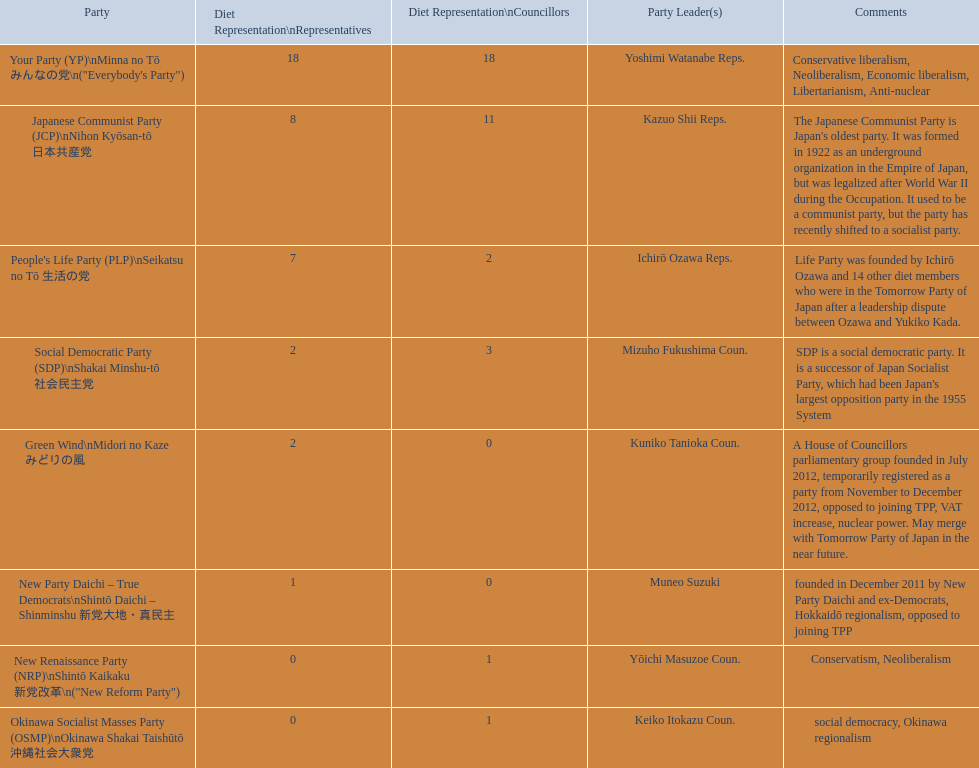How many representatives come from the green wind party? 2. 